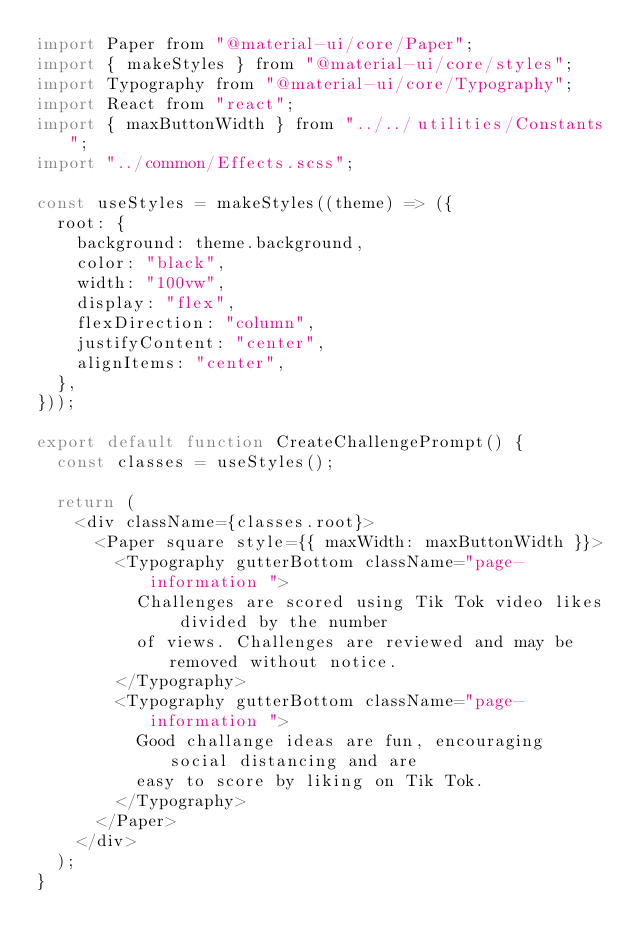<code> <loc_0><loc_0><loc_500><loc_500><_JavaScript_>import Paper from "@material-ui/core/Paper";
import { makeStyles } from "@material-ui/core/styles";
import Typography from "@material-ui/core/Typography";
import React from "react";
import { maxButtonWidth } from "../../utilities/Constants";
import "../common/Effects.scss";

const useStyles = makeStyles((theme) => ({
  root: {
    background: theme.background,
    color: "black",
    width: "100vw",
    display: "flex",
    flexDirection: "column",
    justifyContent: "center",
    alignItems: "center",
  },
}));

export default function CreateChallengePrompt() {
  const classes = useStyles();

  return (
    <div className={classes.root}>
      <Paper square style={{ maxWidth: maxButtonWidth }}>
        <Typography gutterBottom className="page-information ">
          Challenges are scored using Tik Tok video likes divided by the number
          of views. Challenges are reviewed and may be removed without notice.
        </Typography>
        <Typography gutterBottom className="page-information ">
          Good challange ideas are fun, encouraging social distancing and are
          easy to score by liking on Tik Tok.
        </Typography>
      </Paper>
    </div>
  );
}
</code> 